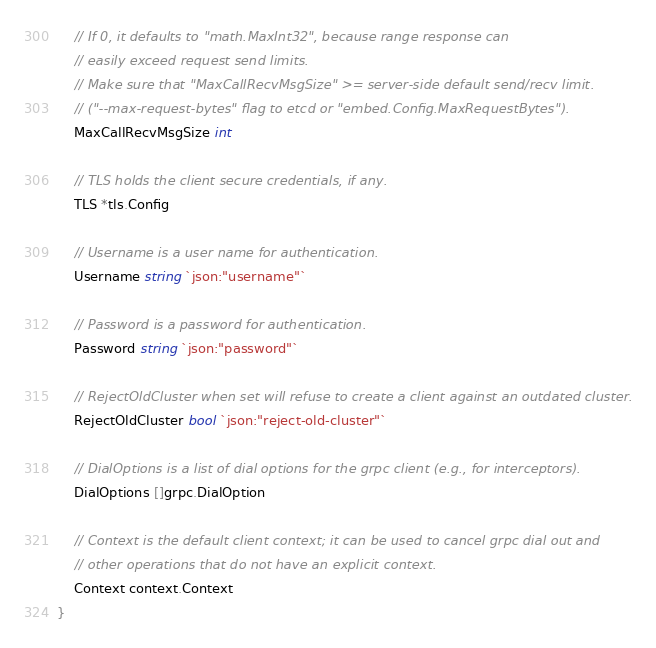Convert code to text. <code><loc_0><loc_0><loc_500><loc_500><_Go_>	// If 0, it defaults to "math.MaxInt32", because range response can
	// easily exceed request send limits.
	// Make sure that "MaxCallRecvMsgSize" >= server-side default send/recv limit.
	// ("--max-request-bytes" flag to etcd or "embed.Config.MaxRequestBytes").
	MaxCallRecvMsgSize int

	// TLS holds the client secure credentials, if any.
	TLS *tls.Config

	// Username is a user name for authentication.
	Username string `json:"username"`

	// Password is a password for authentication.
	Password string `json:"password"`

	// RejectOldCluster when set will refuse to create a client against an outdated cluster.
	RejectOldCluster bool `json:"reject-old-cluster"`

	// DialOptions is a list of dial options for the grpc client (e.g., for interceptors).
	DialOptions []grpc.DialOption

	// Context is the default client context; it can be used to cancel grpc dial out and
	// other operations that do not have an explicit context.
	Context context.Context
}
</code> 